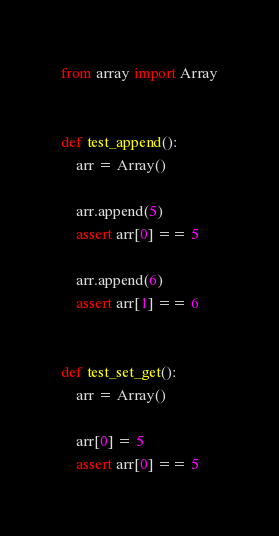Convert code to text. <code><loc_0><loc_0><loc_500><loc_500><_Python_>from array import Array


def test_append():
    arr = Array()

    arr.append(5)
    assert arr[0] == 5

    arr.append(6)
    assert arr[1] == 6


def test_set_get():
    arr = Array()

    arr[0] = 5
    assert arr[0] == 5
</code> 